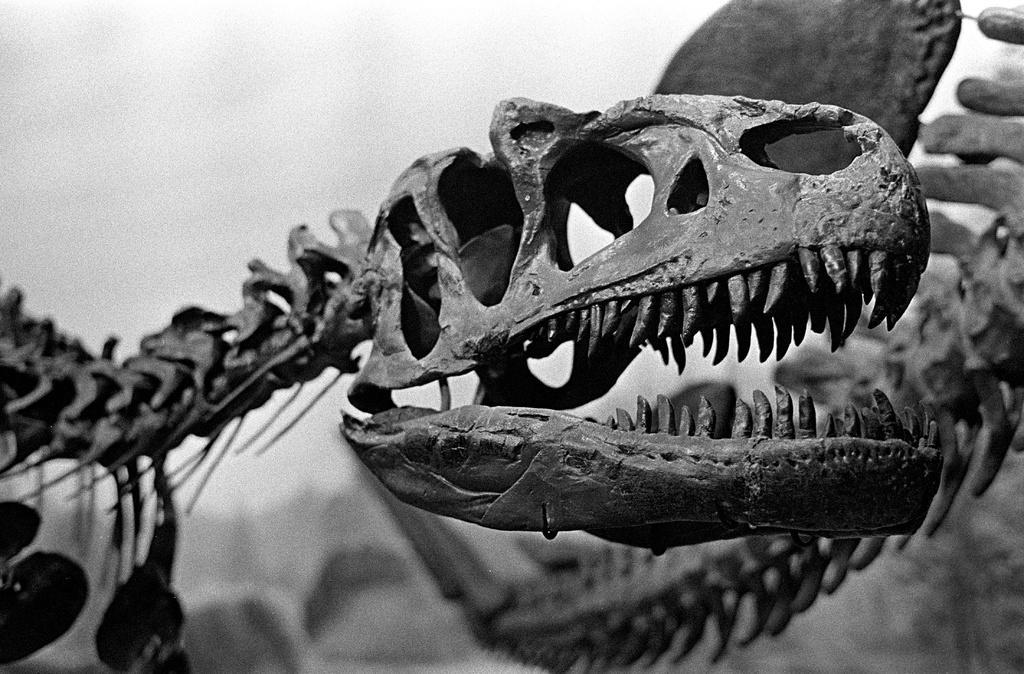In one or two sentences, can you explain what this image depicts? This is a black and white pic. We can see skeletons of the animals. In the background the image is not clear to describe. 